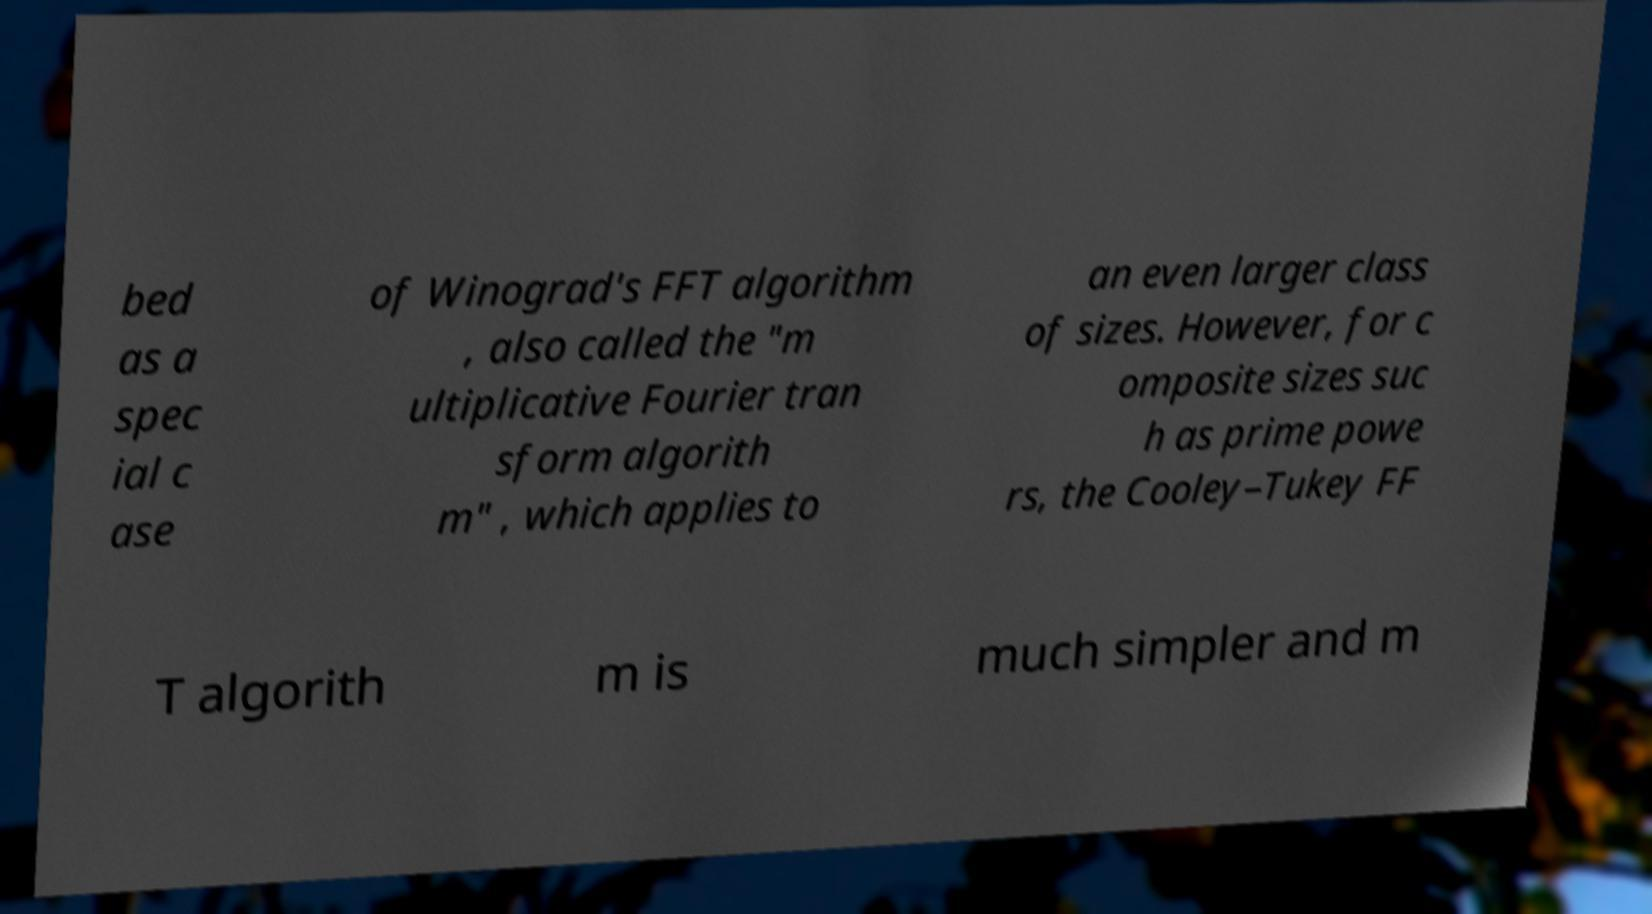For documentation purposes, I need the text within this image transcribed. Could you provide that? bed as a spec ial c ase of Winograd's FFT algorithm , also called the "m ultiplicative Fourier tran sform algorith m" , which applies to an even larger class of sizes. However, for c omposite sizes suc h as prime powe rs, the Cooley–Tukey FF T algorith m is much simpler and m 